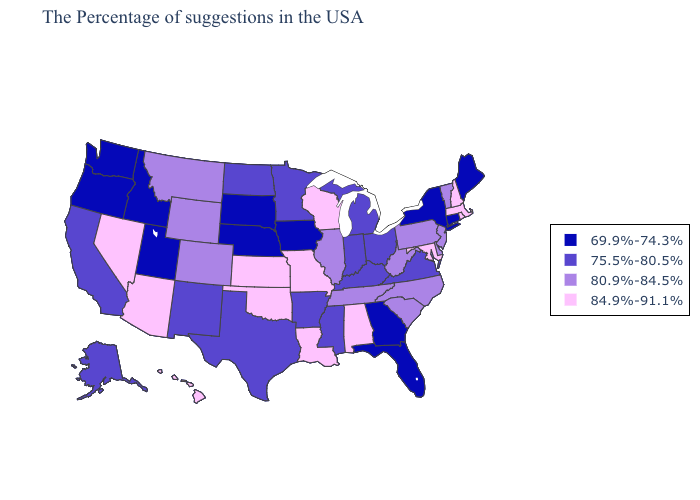Name the states that have a value in the range 80.9%-84.5%?
Give a very brief answer. Vermont, New Jersey, Delaware, Pennsylvania, North Carolina, South Carolina, West Virginia, Tennessee, Illinois, Wyoming, Colorado, Montana. Does the first symbol in the legend represent the smallest category?
Concise answer only. Yes. What is the highest value in the USA?
Concise answer only. 84.9%-91.1%. Does Pennsylvania have the highest value in the Northeast?
Answer briefly. No. Which states have the highest value in the USA?
Give a very brief answer. Massachusetts, Rhode Island, New Hampshire, Maryland, Alabama, Wisconsin, Louisiana, Missouri, Kansas, Oklahoma, Arizona, Nevada, Hawaii. Among the states that border Maine , which have the highest value?
Quick response, please. New Hampshire. Does Hawaii have the highest value in the West?
Be succinct. Yes. What is the highest value in the USA?
Give a very brief answer. 84.9%-91.1%. What is the value of Arizona?
Answer briefly. 84.9%-91.1%. Is the legend a continuous bar?
Short answer required. No. What is the lowest value in the Northeast?
Concise answer only. 69.9%-74.3%. What is the highest value in states that border Mississippi?
Be succinct. 84.9%-91.1%. What is the value of Idaho?
Answer briefly. 69.9%-74.3%. What is the value of Wyoming?
Concise answer only. 80.9%-84.5%. Name the states that have a value in the range 75.5%-80.5%?
Quick response, please. Virginia, Ohio, Michigan, Kentucky, Indiana, Mississippi, Arkansas, Minnesota, Texas, North Dakota, New Mexico, California, Alaska. 